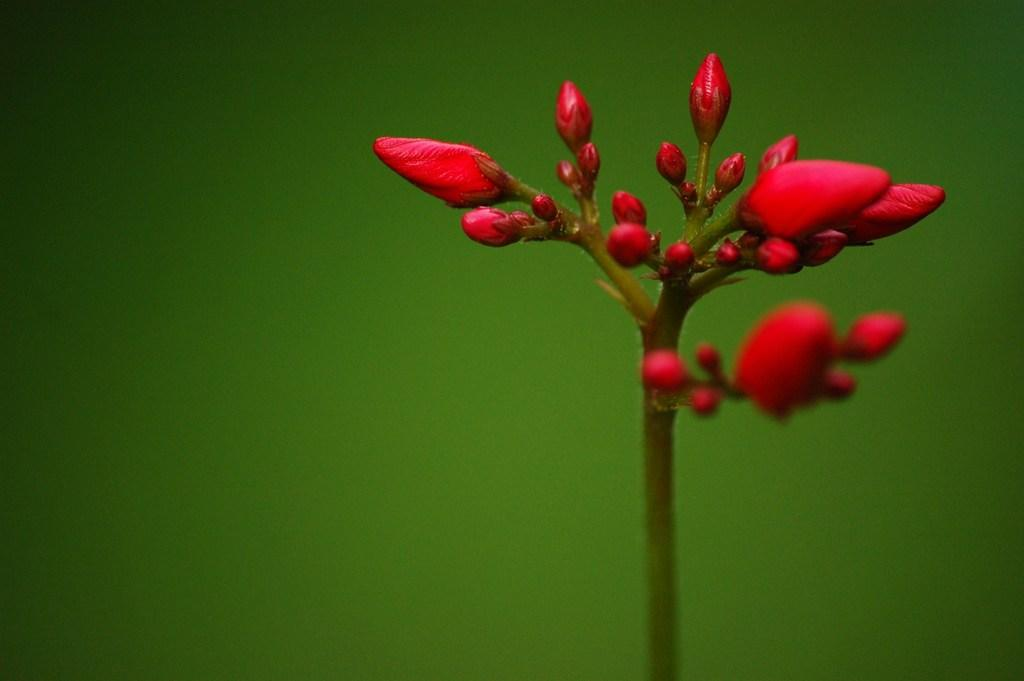What can be seen in the image? There are buds in the image. How are the buds arranged or connected? The buds are connected to a stem. What type of wrench is being used to trim the tree in the image? There is no tree or wrench present in the image; it only features buds connected to a stem. 